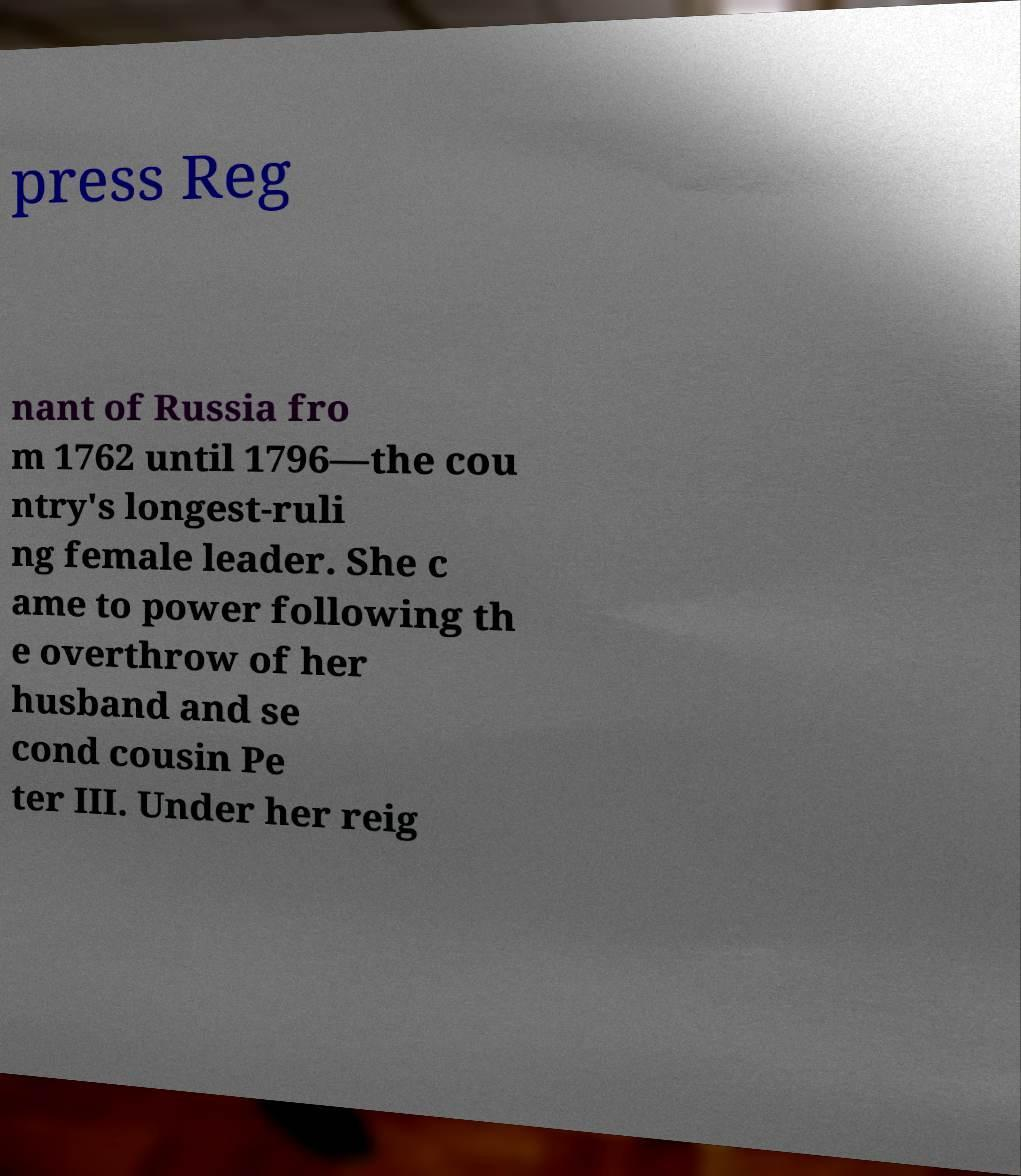Can you accurately transcribe the text from the provided image for me? press Reg nant of Russia fro m 1762 until 1796—the cou ntry's longest-ruli ng female leader. She c ame to power following th e overthrow of her husband and se cond cousin Pe ter III. Under her reig 